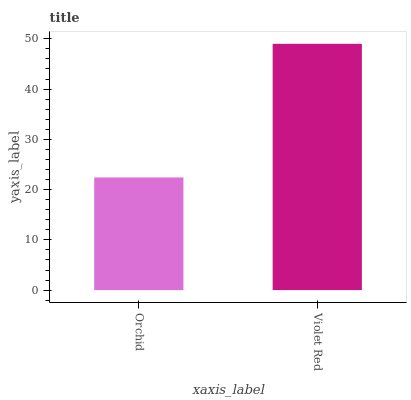Is Orchid the minimum?
Answer yes or no. Yes. Is Violet Red the maximum?
Answer yes or no. Yes. Is Violet Red the minimum?
Answer yes or no. No. Is Violet Red greater than Orchid?
Answer yes or no. Yes. Is Orchid less than Violet Red?
Answer yes or no. Yes. Is Orchid greater than Violet Red?
Answer yes or no. No. Is Violet Red less than Orchid?
Answer yes or no. No. Is Violet Red the high median?
Answer yes or no. Yes. Is Orchid the low median?
Answer yes or no. Yes. Is Orchid the high median?
Answer yes or no. No. Is Violet Red the low median?
Answer yes or no. No. 